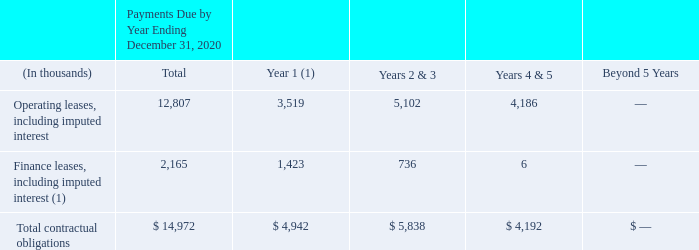Contractual Obligations and Contingent Liabilities and Commitments
Our principal commitments consist primarily of obligations under operating and financing leases, which include among others, certain leases of our offices, colocations and servers as well as contractual commitment related network infrastructure and data center operations. The following table summarizes our commitments to settle contractual obligations in cash as of December 31, 2019:
(1) Finance leases are related to servers and network infrastructure and our data center operations.
As of December 31, 2019, we had severance agreements with certain employees which would require us to pay up to approximately $6.4 million if all such employees were terminated from employment with our Company following a triggering event (e.g., change of control) as defined in the severance agreements.
What was the total payments due by year ending december 31, 2020 for operating leases, including imputed interest and for Finance leases, including imputed interest, respectively?
Answer scale should be: thousand. 12,807, 2,165. What are the components that are related to finance leases? Servers and network infrastructure, data center operations. How much would the company have to pay up to as defined in the severance agreements as of December 31, 2019 following a triggering event in the company? Approximately $6.4 million. What is the payments due for Operating leases, including imputed interest from years 1 to 3?
Answer scale should be: thousand. 3,519+5,102
Answer: 8621. What is the percentage constitution of total operating leases among the total contractual obligations?
Answer scale should be: percent. 12,807/14,972
Answer: 85.54. How much more in total contractual obligations does the company expect to spend in Year 1 than Years 4 & 5?
Answer scale should be: thousand.  4,942-4,192
Answer: 750. 